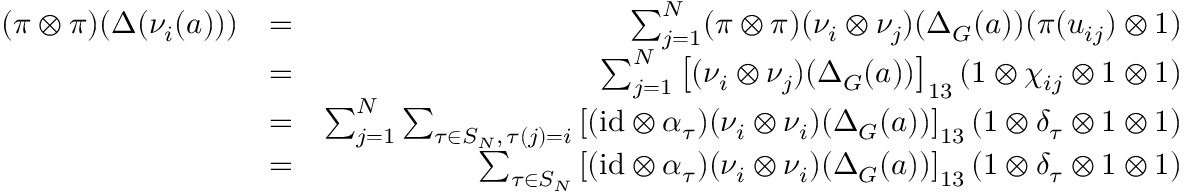<formula> <loc_0><loc_0><loc_500><loc_500>\begin{array} { r l r } { ( \pi \otimes \pi ) ( \Delta ( \nu _ { i } ( a ) ) ) } & { = } & { \sum _ { j = 1 } ^ { N } ( \pi \otimes \pi ) ( \nu _ { i } \otimes \nu _ { j } ) ( \Delta _ { G } ( a ) ) ( \pi ( u _ { i j } ) \otimes 1 ) } \\ & { = } & { \sum _ { j = 1 } ^ { N } \left [ ( \nu _ { i } \otimes \nu _ { j } ) ( \Delta _ { G } ( a ) ) \right ] _ { 1 3 } ( 1 \otimes \chi _ { i j } \otimes 1 \otimes 1 ) } \\ & { = } & { \sum _ { j = 1 } ^ { N } \sum _ { \tau \in S _ { N } , \, \tau ( j ) = i } \left [ ( i d \otimes \alpha _ { \tau } ) ( \nu _ { i } \otimes \nu _ { i } ) ( \Delta _ { G } ( a ) ) \right ] _ { 1 3 } ( 1 \otimes \delta _ { \tau } \otimes 1 \otimes 1 ) } \\ & { = } & { \sum _ { \tau \in S _ { N } } \left [ ( i d \otimes \alpha _ { \tau } ) ( \nu _ { i } \otimes \nu _ { i } ) ( \Delta _ { G } ( a ) ) \right ] _ { 1 3 } ( 1 \otimes \delta _ { \tau } \otimes 1 \otimes 1 ) } \end{array}</formula> 